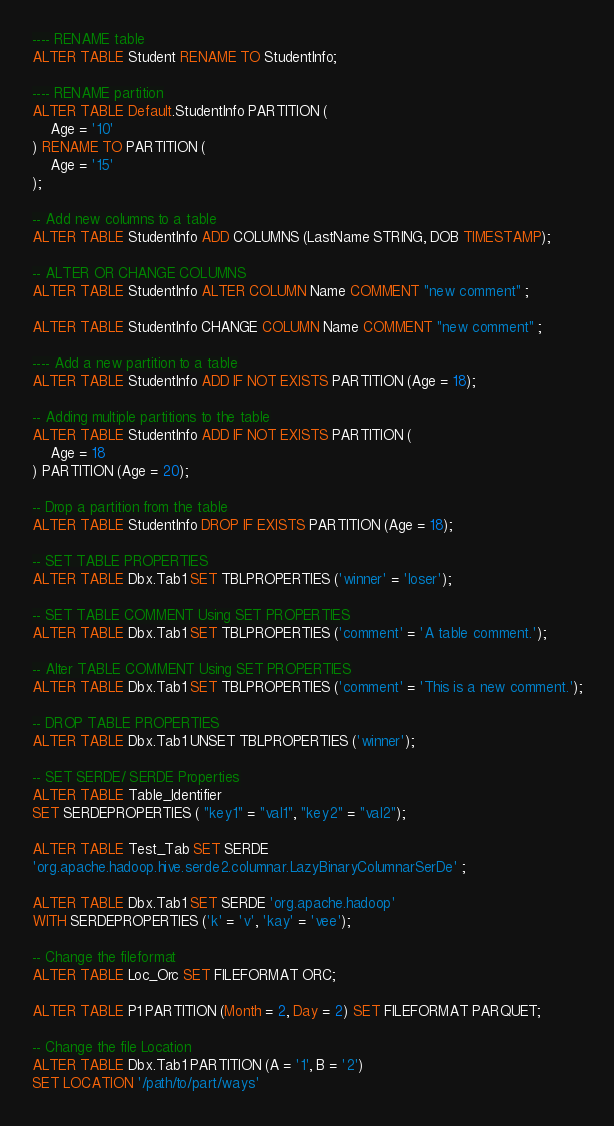Convert code to text. <code><loc_0><loc_0><loc_500><loc_500><_SQL_>---- RENAME table
ALTER TABLE Student RENAME TO StudentInfo;

---- RENAME partition
ALTER TABLE Default.StudentInfo PARTITION (
    Age = '10'
) RENAME TO PARTITION (
    Age = '15'
);

-- Add new columns to a table
ALTER TABLE StudentInfo ADD COLUMNS (LastName STRING, DOB TIMESTAMP);

-- ALTER OR CHANGE COLUMNS
ALTER TABLE StudentInfo ALTER COLUMN Name COMMENT "new comment" ;

ALTER TABLE StudentInfo CHANGE COLUMN Name COMMENT "new comment" ;

---- Add a new partition to a table
ALTER TABLE StudentInfo ADD IF NOT EXISTS PARTITION (Age = 18);

-- Adding multiple partitions to the table
ALTER TABLE StudentInfo ADD IF NOT EXISTS PARTITION (
    Age = 18
) PARTITION (Age = 20);

-- Drop a partition from the table
ALTER TABLE StudentInfo DROP IF EXISTS PARTITION (Age = 18);

-- SET TABLE PROPERTIES
ALTER TABLE Dbx.Tab1 SET TBLPROPERTIES ('winner' = 'loser');

-- SET TABLE COMMENT Using SET PROPERTIES
ALTER TABLE Dbx.Tab1 SET TBLPROPERTIES ('comment' = 'A table comment.');

-- Alter TABLE COMMENT Using SET PROPERTIES
ALTER TABLE Dbx.Tab1 SET TBLPROPERTIES ('comment' = 'This is a new comment.');

-- DROP TABLE PROPERTIES
ALTER TABLE Dbx.Tab1 UNSET TBLPROPERTIES ('winner');

-- SET SERDE/ SERDE Properties
ALTER TABLE Table_Identifier
SET SERDEPROPERTIES ( "key1" = "val1", "key2" = "val2");

ALTER TABLE Test_Tab SET SERDE
'org.apache.hadoop.hive.serde2.columnar.LazyBinaryColumnarSerDe' ;

ALTER TABLE Dbx.Tab1 SET SERDE 'org.apache.hadoop'
WITH SERDEPROPERTIES ('k' = 'v', 'kay' = 'vee');

-- Change the fileformat
ALTER TABLE Loc_Orc SET FILEFORMAT ORC;

ALTER TABLE P1 PARTITION (Month = 2, Day = 2) SET FILEFORMAT PARQUET;

-- Change the file Location
ALTER TABLE Dbx.Tab1 PARTITION (A = '1', B = '2')
SET LOCATION '/path/to/part/ways'
</code> 